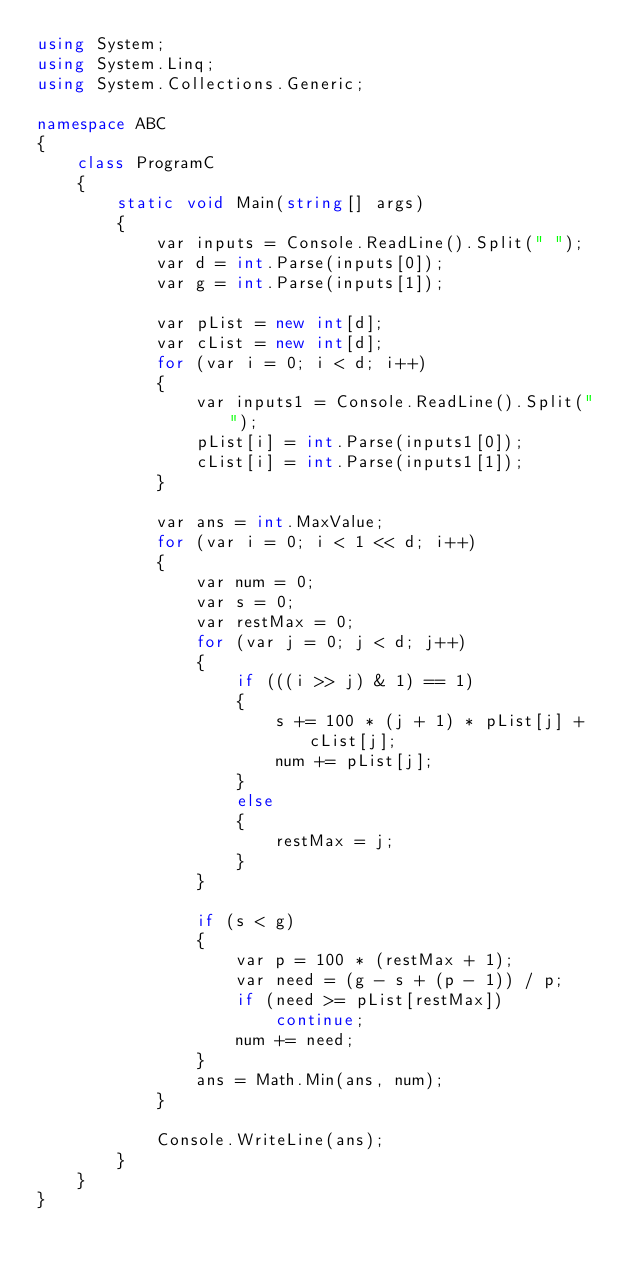<code> <loc_0><loc_0><loc_500><loc_500><_C#_>using System;
using System.Linq;
using System.Collections.Generic;

namespace ABC
{
    class ProgramC
    {
        static void Main(string[] args)
        {
            var inputs = Console.ReadLine().Split(" ");
            var d = int.Parse(inputs[0]);
            var g = int.Parse(inputs[1]);

            var pList = new int[d];
            var cList = new int[d];
            for (var i = 0; i < d; i++)
            {
                var inputs1 = Console.ReadLine().Split(" ");
                pList[i] = int.Parse(inputs1[0]);
                cList[i] = int.Parse(inputs1[1]);
            }

            var ans = int.MaxValue;
            for (var i = 0; i < 1 << d; i++)
            {
                var num = 0;
                var s = 0;
                var restMax = 0;
                for (var j = 0; j < d; j++)
                {
                    if (((i >> j) & 1) == 1)
                    {
                        s += 100 * (j + 1) * pList[j] + cList[j];
                        num += pList[j];
                    }
                    else
                    {
                        restMax = j;
                    }
                }

                if (s < g)
                {
                    var p = 100 * (restMax + 1);
                    var need = (g - s + (p - 1)) / p;
                    if (need >= pList[restMax])
                        continue;
                    num += need;
                }
                ans = Math.Min(ans, num);
            }

            Console.WriteLine(ans);
        }
    }
}
</code> 